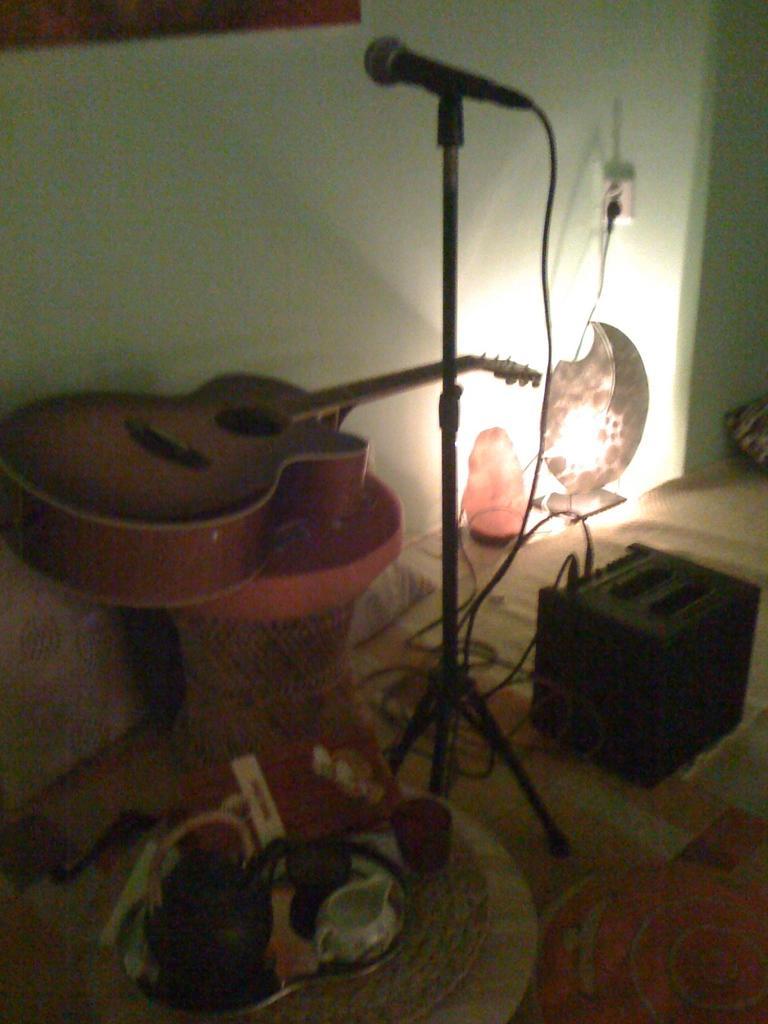Can you describe this image briefly? On the background of the picture we can see a wall. This is a light. here we can see one chair and on the chair there is a guitar. This is an electronic device. Here we can see a plate and on the plate we can see some containers. this is a book. this is a floor carpet. 